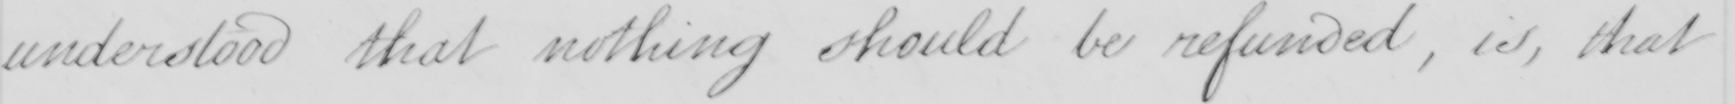What text is written in this handwritten line? understood that nothing should be refunded, is, that 